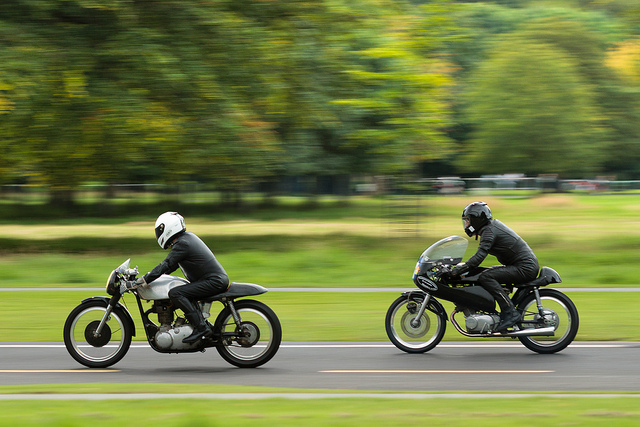Describe the technique used to capture this image. This image was taken using a technique called panning, where the camera follows the moving subject at the same speed. The result is a sharply focused subject against a blurred background, emphasizing motion. 